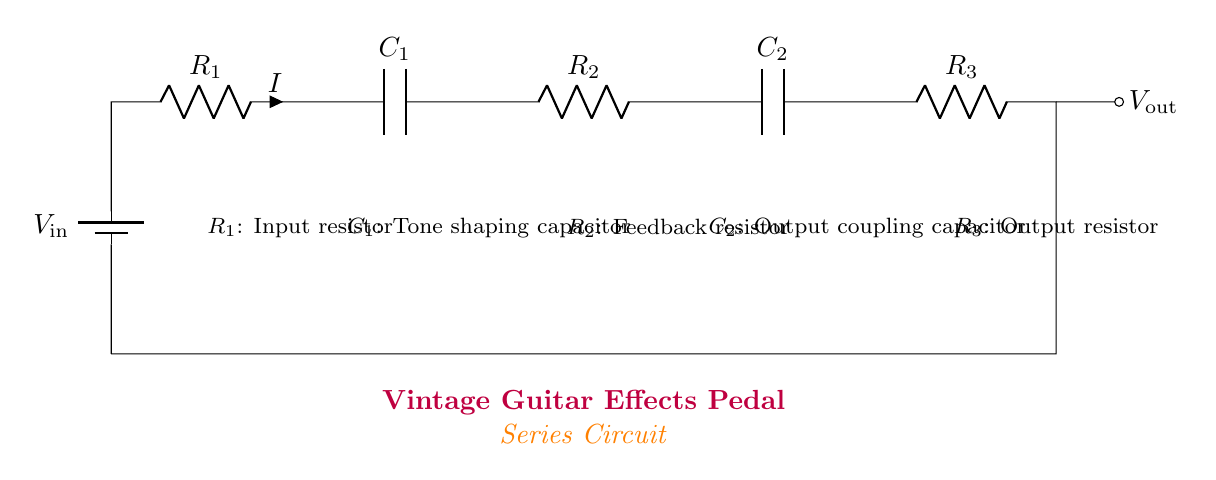What is the input resistor in this circuit? The input resistor is indicated as R1, which is the first resistor connected immediately after the input voltage source.
Answer: R1 What does C1 represent in this circuit? C1 denotes the tone shaping capacitor, which is used to modify the frequency response of the signal passing through it.
Answer: Tone shaping capacitor What is the function of R3 in this circuit? R3 is the output resistor, and it serves to limit the current flowing out of the circuit, facilitating safe interaction with subsequent stages or components.
Answer: Output resistor How many capacitors are present in this circuit? The circuit diagram contains two capacitors, C1 and C2, each serving specific roles in shaping and coupling the audio signal.
Answer: Two What type of circuit is illustrated in the diagram? The circuit type shown here is a series circuit, as all components are connected in a single path for the current to flow through sequentially.
Answer: Series circuit Which component influences feedback in this circuit? The feedback mechanism is influenced by R2, which is the feedback resistor linked after the first capacitor and before the second.
Answer: R2 What is the output voltage represented as in this schematic? The output voltage in the schematic is designated as Vout, located at the end of the circuit after R3.
Answer: Vout 